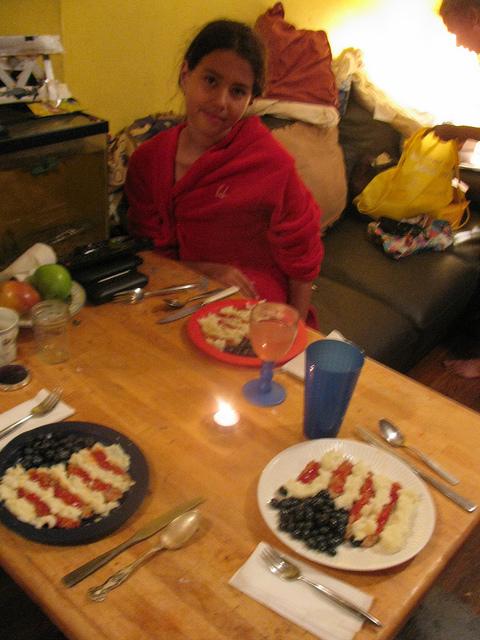What are they drinking with the doughnuts and chips?
Be succinct. Juice. Are all immediate family members present?
Keep it brief. No. What room is this?
Answer briefly. Dining room. What is in the black cup?
Concise answer only. Water. How many people are sitting at the table?
Give a very brief answer. 1. What  special day are these people celebrating?
Short answer required. Birthday. 